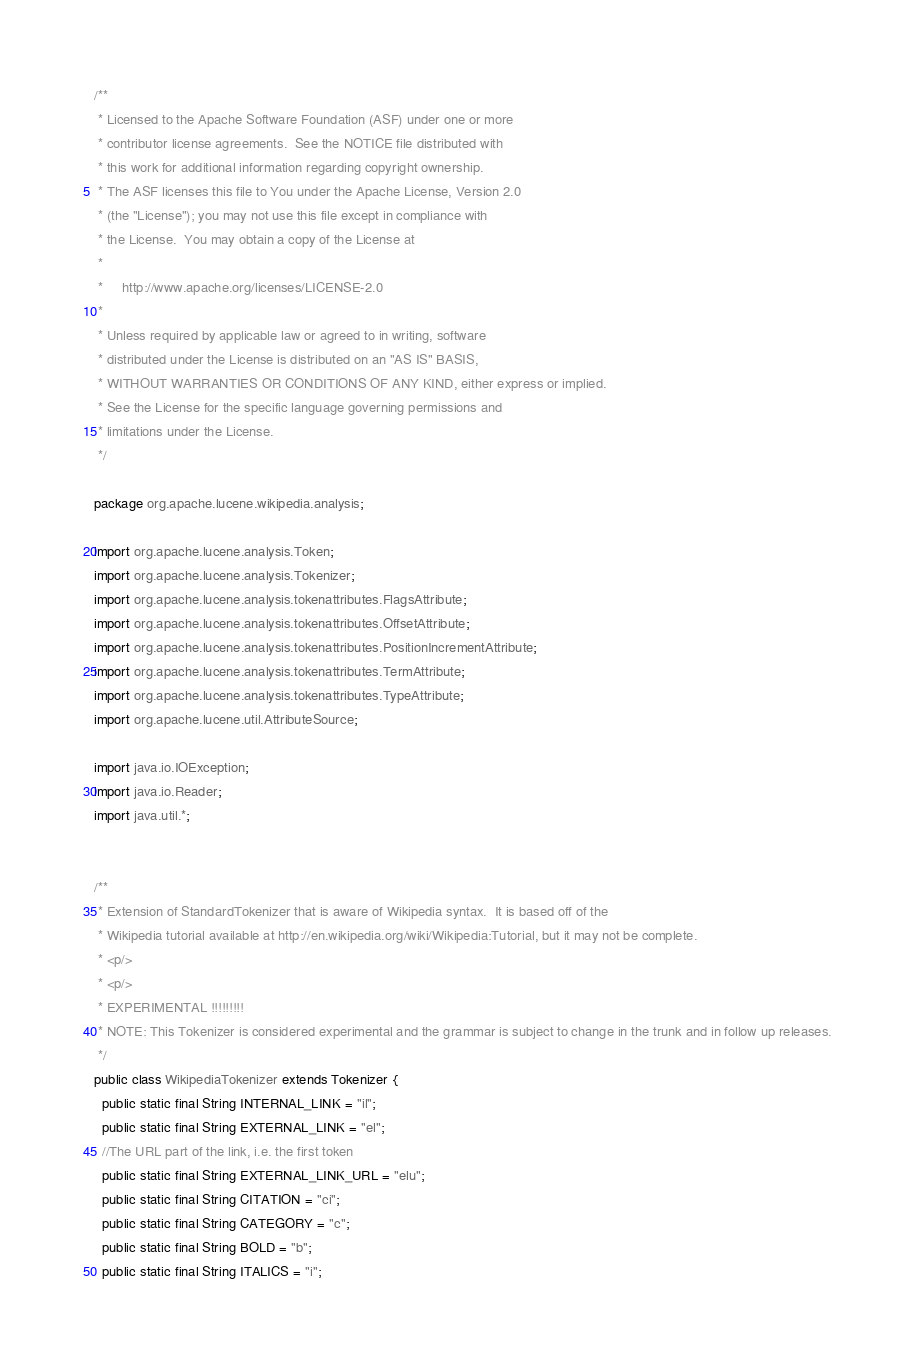Convert code to text. <code><loc_0><loc_0><loc_500><loc_500><_Java_>/**
 * Licensed to the Apache Software Foundation (ASF) under one or more
 * contributor license agreements.  See the NOTICE file distributed with
 * this work for additional information regarding copyright ownership.
 * The ASF licenses this file to You under the Apache License, Version 2.0
 * (the "License"); you may not use this file except in compliance with
 * the License.  You may obtain a copy of the License at
 *
 *     http://www.apache.org/licenses/LICENSE-2.0
 *
 * Unless required by applicable law or agreed to in writing, software
 * distributed under the License is distributed on an "AS IS" BASIS,
 * WITHOUT WARRANTIES OR CONDITIONS OF ANY KIND, either express or implied.
 * See the License for the specific language governing permissions and
 * limitations under the License.
 */

package org.apache.lucene.wikipedia.analysis;

import org.apache.lucene.analysis.Token;
import org.apache.lucene.analysis.Tokenizer;
import org.apache.lucene.analysis.tokenattributes.FlagsAttribute;
import org.apache.lucene.analysis.tokenattributes.OffsetAttribute;
import org.apache.lucene.analysis.tokenattributes.PositionIncrementAttribute;
import org.apache.lucene.analysis.tokenattributes.TermAttribute;
import org.apache.lucene.analysis.tokenattributes.TypeAttribute;
import org.apache.lucene.util.AttributeSource;

import java.io.IOException;
import java.io.Reader;
import java.util.*;


/**
 * Extension of StandardTokenizer that is aware of Wikipedia syntax.  It is based off of the
 * Wikipedia tutorial available at http://en.wikipedia.org/wiki/Wikipedia:Tutorial, but it may not be complete.
 * <p/>
 * <p/>
 * EXPERIMENTAL !!!!!!!!!
 * NOTE: This Tokenizer is considered experimental and the grammar is subject to change in the trunk and in follow up releases.
 */
public class WikipediaTokenizer extends Tokenizer {
  public static final String INTERNAL_LINK = "il";
  public static final String EXTERNAL_LINK = "el";
  //The URL part of the link, i.e. the first token
  public static final String EXTERNAL_LINK_URL = "elu";
  public static final String CITATION = "ci";
  public static final String CATEGORY = "c";
  public static final String BOLD = "b";
  public static final String ITALICS = "i";</code> 